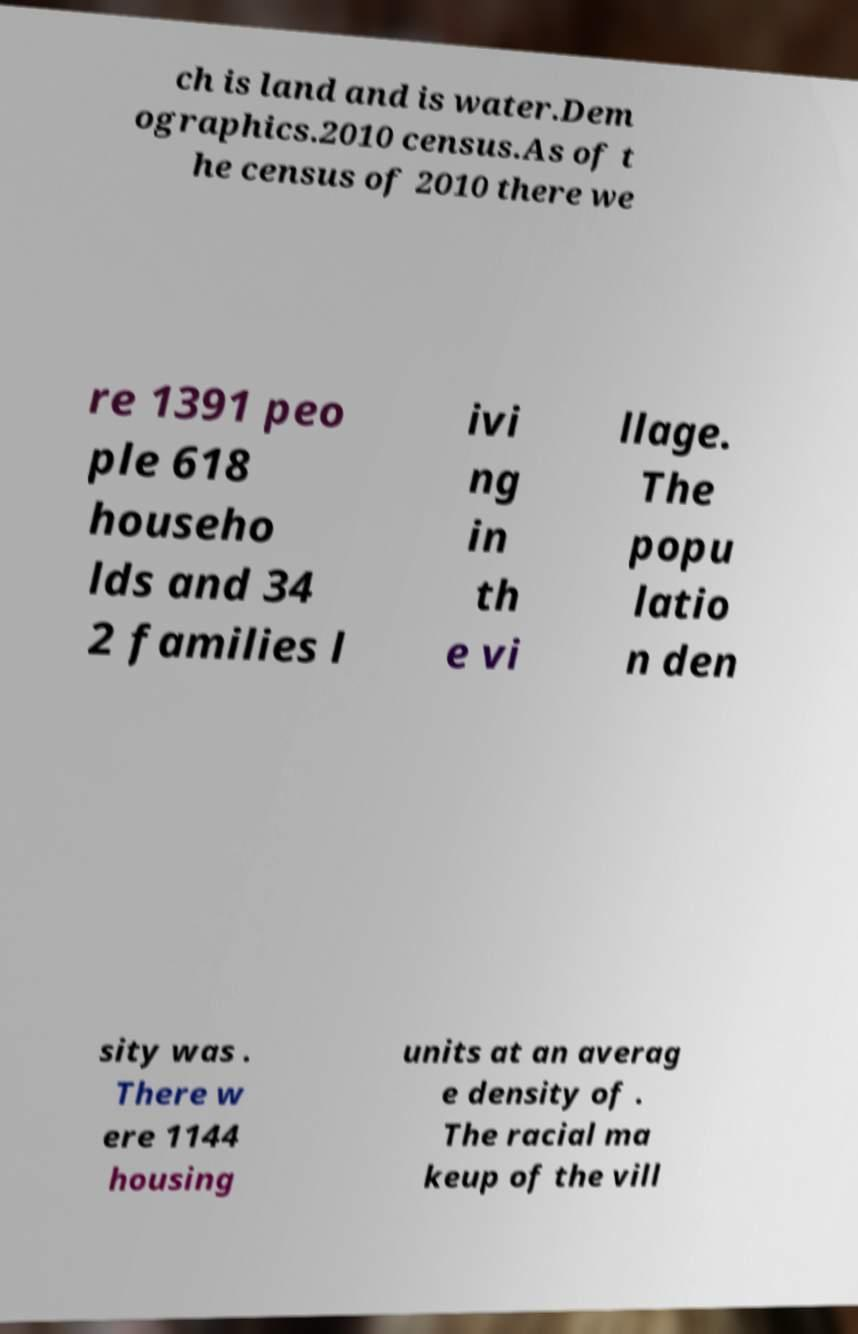What messages or text are displayed in this image? I need them in a readable, typed format. ch is land and is water.Dem ographics.2010 census.As of t he census of 2010 there we re 1391 peo ple 618 househo lds and 34 2 families l ivi ng in th e vi llage. The popu latio n den sity was . There w ere 1144 housing units at an averag e density of . The racial ma keup of the vill 